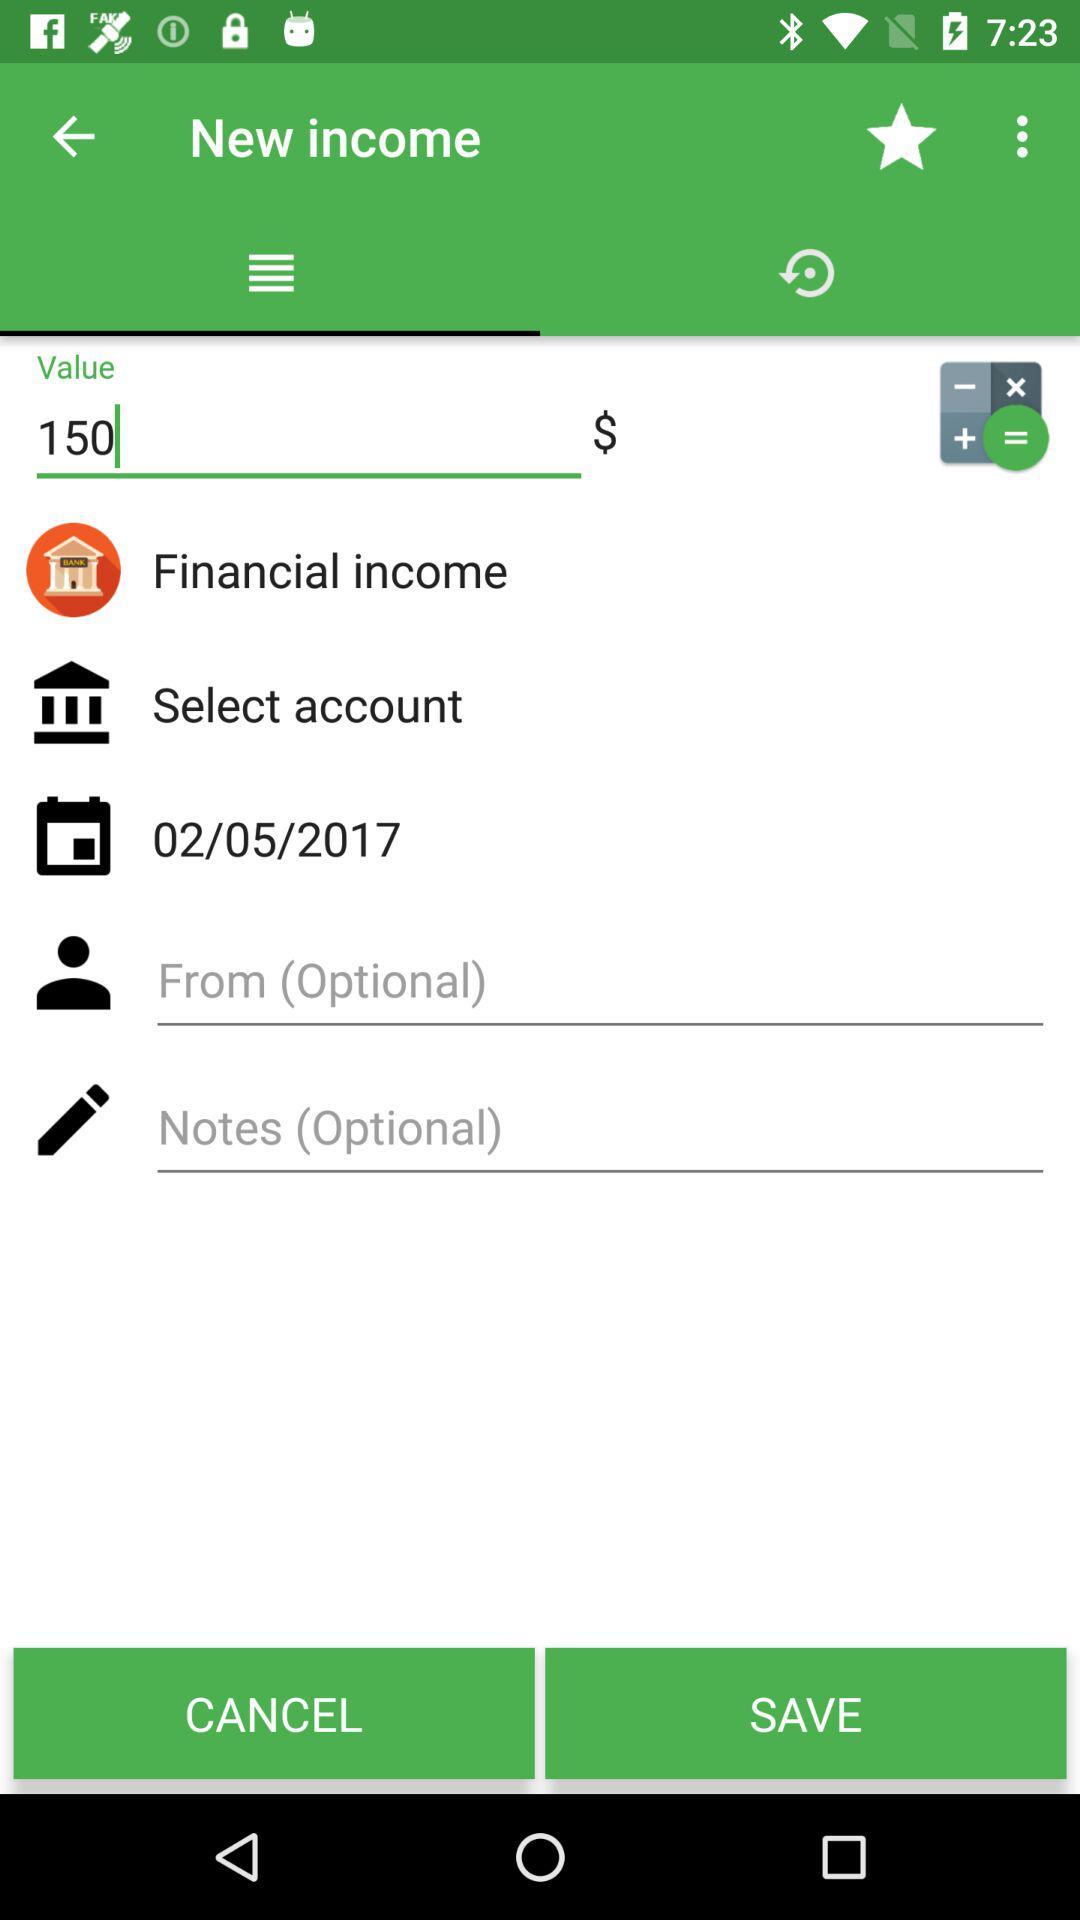What is the date of this income?
Answer the question using a single word or phrase. 02/05/2017 